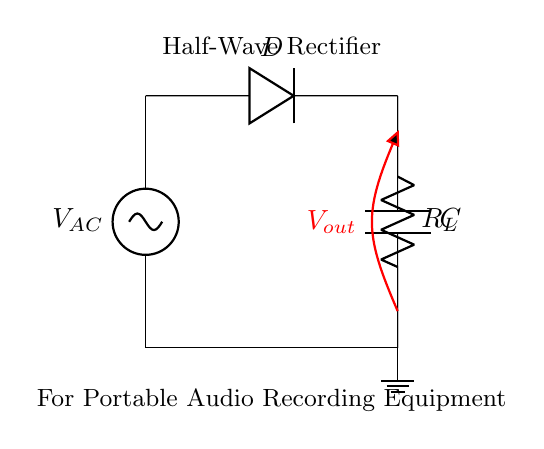What is the power source in this circuit? The power source is labeled as V_AC, which signifies an alternating current (AC) source. It serves as the input for this rectifier circuit.
Answer: V_AC What component converts AC to DC? The diode labeled D is the component responsible for converting the alternating current (AC) into direct current (DC) by allowing current to flow only in one direction.
Answer: D What is the role of the capacitor in this circuit? The capacitor labeled C smooths out the output voltage by charging during the peaks of the AC input and discharging when the input drops, providing a more stable DC output.
Answer: Smooths voltage What is the load resistor's designation in this rectifier? The resistor is labeled R_L, which indicates it is a load resistor that consumes power from the output DC voltage generated by the rectifier circuit.
Answer: R_L Which type of rectification is used in this circuit? The circuit is a half-wave rectifier, which means that it only uses one half of the incoming AC waveform to generate a DC output.
Answer: Half-wave How many diodes are present in this circuit? There is only one diode in the circuit, as indicated by the single label D, which is necessary for performing the half-wave rectification.
Answer: One What would happen to the output voltage if the diode were removed? Without the diode, the circuit would not have any rectification, and the output voltage would continuously fluctuate with the AC input, resulting in no usable DC voltage.
Answer: No usable voltage 